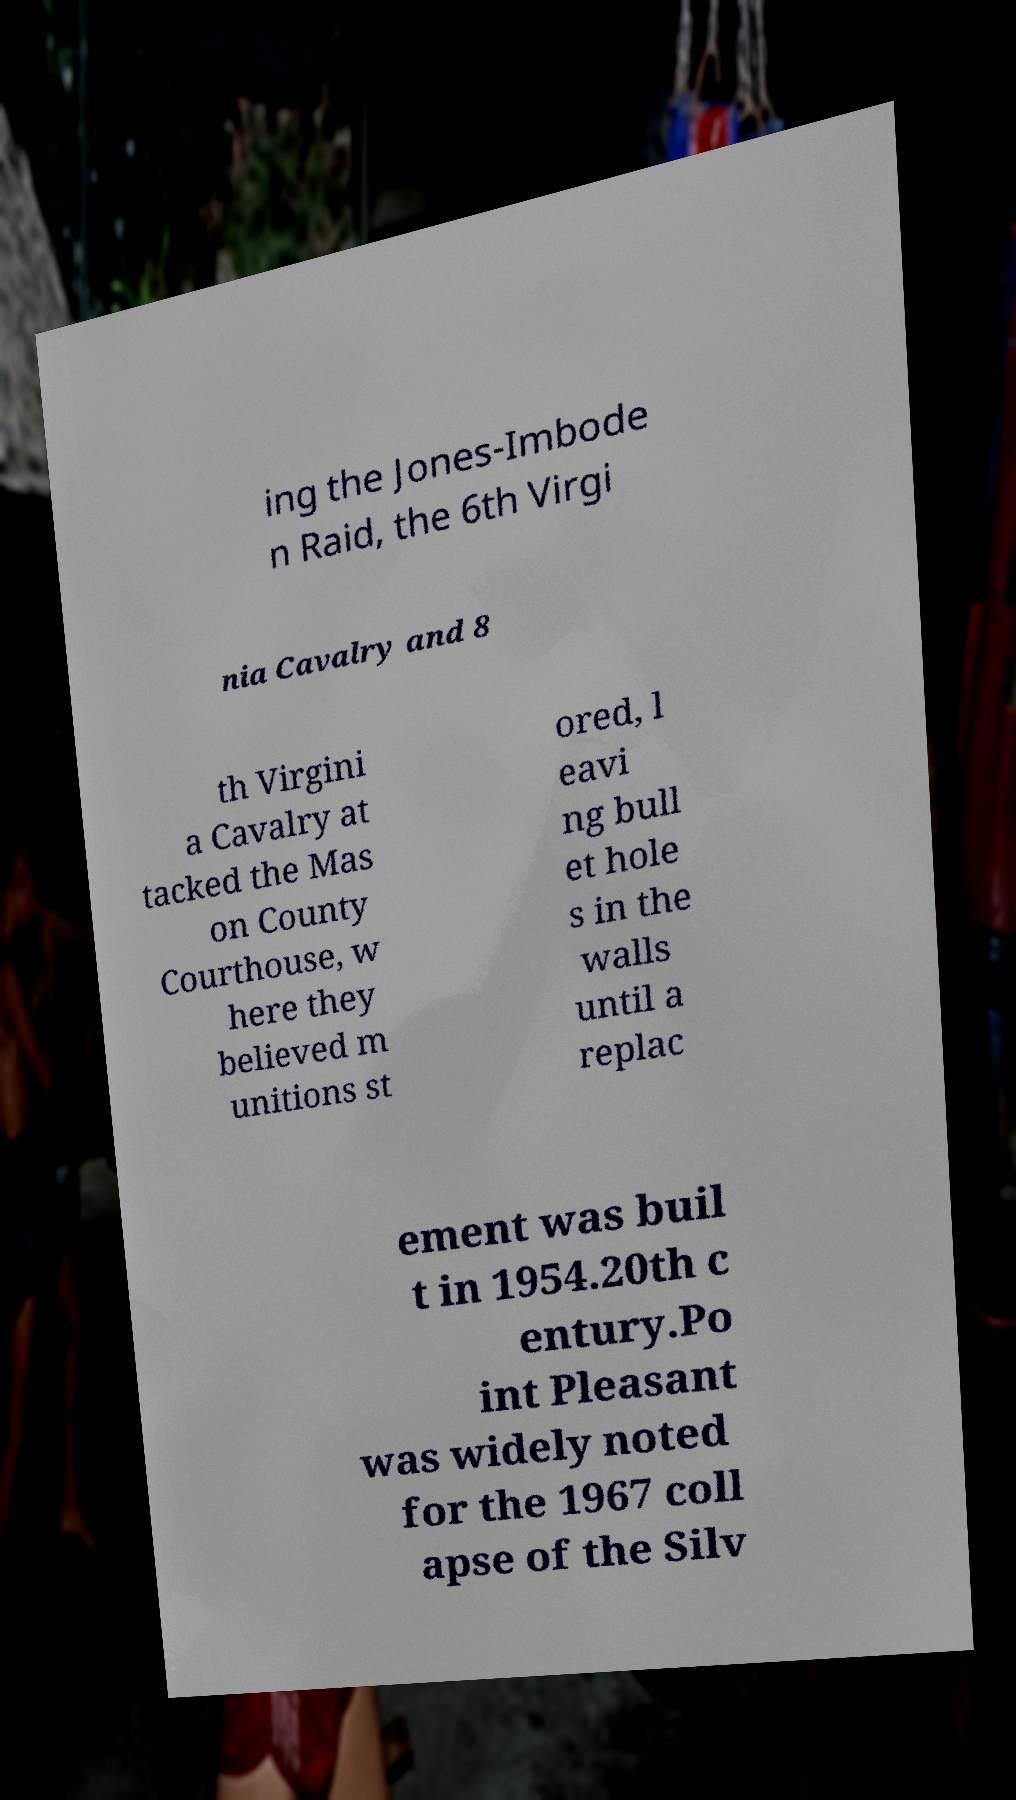For documentation purposes, I need the text within this image transcribed. Could you provide that? ing the Jones-Imbode n Raid, the 6th Virgi nia Cavalry and 8 th Virgini a Cavalry at tacked the Mas on County Courthouse, w here they believed m unitions st ored, l eavi ng bull et hole s in the walls until a replac ement was buil t in 1954.20th c entury.Po int Pleasant was widely noted for the 1967 coll apse of the Silv 